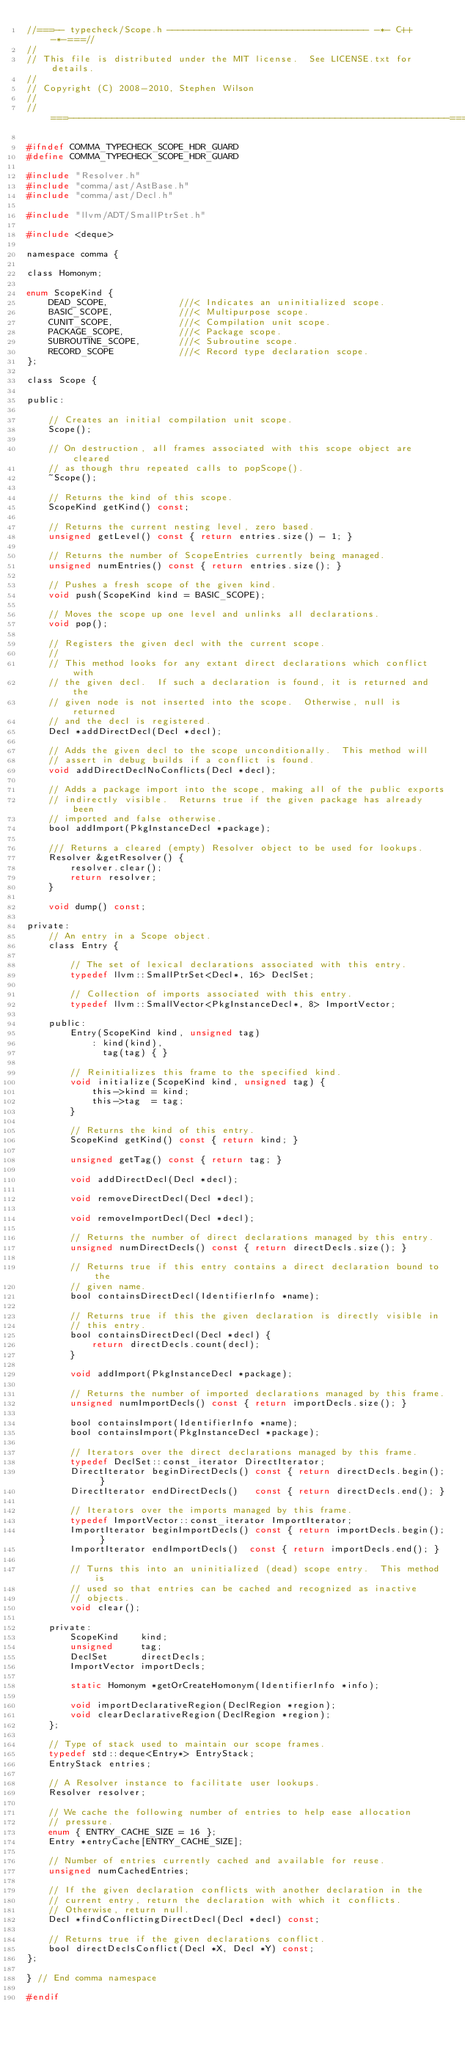<code> <loc_0><loc_0><loc_500><loc_500><_C_>//===-- typecheck/Scope.h ------------------------------------- -*- C++ -*-===//
//
// This file is distributed under the MIT license.  See LICENSE.txt for details.
//
// Copyright (C) 2008-2010, Stephen Wilson
//
//===----------------------------------------------------------------------===//

#ifndef COMMA_TYPECHECK_SCOPE_HDR_GUARD
#define COMMA_TYPECHECK_SCOPE_HDR_GUARD

#include "Resolver.h"
#include "comma/ast/AstBase.h"
#include "comma/ast/Decl.h"

#include "llvm/ADT/SmallPtrSet.h"

#include <deque>

namespace comma {

class Homonym;

enum ScopeKind {
    DEAD_SCOPE,             ///< Indicates an uninitialized scope.
    BASIC_SCOPE,            ///< Multipurpose scope.
    CUNIT_SCOPE,            ///< Compilation unit scope.
    PACKAGE_SCOPE,          ///< Package scope.
    SUBROUTINE_SCOPE,       ///< Subroutine scope.
    RECORD_SCOPE            ///< Record type declaration scope.
};

class Scope {

public:

    // Creates an initial compilation unit scope.
    Scope();

    // On destruction, all frames associated with this scope object are cleared
    // as though thru repeated calls to popScope().
    ~Scope();

    // Returns the kind of this scope.
    ScopeKind getKind() const;

    // Returns the current nesting level, zero based.
    unsigned getLevel() const { return entries.size() - 1; }

    // Returns the number of ScopeEntries currently being managed.
    unsigned numEntries() const { return entries.size(); }

    // Pushes a fresh scope of the given kind.
    void push(ScopeKind kind = BASIC_SCOPE);

    // Moves the scope up one level and unlinks all declarations.
    void pop();

    // Registers the given decl with the current scope.
    //
    // This method looks for any extant direct declarations which conflict with
    // the given decl.  If such a declaration is found, it is returned and the
    // given node is not inserted into the scope.  Otherwise, null is returned
    // and the decl is registered.
    Decl *addDirectDecl(Decl *decl);

    // Adds the given decl to the scope unconditionally.  This method will
    // assert in debug builds if a conflict is found.
    void addDirectDeclNoConflicts(Decl *decl);

    // Adds a package import into the scope, making all of the public exports
    // indirectly visible.  Returns true if the given package has already been
    // imported and false otherwise.
    bool addImport(PkgInstanceDecl *package);

    /// Returns a cleared (empty) Resolver object to be used for lookups.
    Resolver &getResolver() {
        resolver.clear();
        return resolver;
    }

    void dump() const;

private:
    // An entry in a Scope object.
    class Entry {

        // The set of lexical declarations associated with this entry.
        typedef llvm::SmallPtrSet<Decl*, 16> DeclSet;

        // Collection of imports associated with this entry.
        typedef llvm::SmallVector<PkgInstanceDecl*, 8> ImportVector;

    public:
        Entry(ScopeKind kind, unsigned tag)
            : kind(kind),
              tag(tag) { }

        // Reinitializes this frame to the specified kind.
        void initialize(ScopeKind kind, unsigned tag) {
            this->kind = kind;
            this->tag  = tag;
        }

        // Returns the kind of this entry.
        ScopeKind getKind() const { return kind; }

        unsigned getTag() const { return tag; }

        void addDirectDecl(Decl *decl);

        void removeDirectDecl(Decl *decl);

        void removeImportDecl(Decl *decl);

        // Returns the number of direct declarations managed by this entry.
        unsigned numDirectDecls() const { return directDecls.size(); }

        // Returns true if this entry contains a direct declaration bound to the
        // given name.
        bool containsDirectDecl(IdentifierInfo *name);

        // Returns true if this the given declaration is directly visible in
        // this entry.
        bool containsDirectDecl(Decl *decl) {
            return directDecls.count(decl);
        }

        void addImport(PkgInstanceDecl *package);

        // Returns the number of imported declarations managed by this frame.
        unsigned numImportDecls() const { return importDecls.size(); }

        bool containsImport(IdentifierInfo *name);
        bool containsImport(PkgInstanceDecl *package);

        // Iterators over the direct declarations managed by this frame.
        typedef DeclSet::const_iterator DirectIterator;
        DirectIterator beginDirectDecls() const { return directDecls.begin(); }
        DirectIterator endDirectDecls()   const { return directDecls.end(); }

        // Iterators over the imports managed by this frame.
        typedef ImportVector::const_iterator ImportIterator;
        ImportIterator beginImportDecls() const { return importDecls.begin(); }
        ImportIterator endImportDecls()  const { return importDecls.end(); }

        // Turns this into an uninitialized (dead) scope entry.  This method is
        // used so that entries can be cached and recognized as inactive
        // objects.
        void clear();

    private:
        ScopeKind    kind;
        unsigned     tag;
        DeclSet      directDecls;
        ImportVector importDecls;

        static Homonym *getOrCreateHomonym(IdentifierInfo *info);

        void importDeclarativeRegion(DeclRegion *region);
        void clearDeclarativeRegion(DeclRegion *region);
    };

    // Type of stack used to maintain our scope frames.
    typedef std::deque<Entry*> EntryStack;
    EntryStack entries;

    // A Resolver instance to facilitate user lookups.
    Resolver resolver;

    // We cache the following number of entries to help ease allocation
    // pressure.
    enum { ENTRY_CACHE_SIZE = 16 };
    Entry *entryCache[ENTRY_CACHE_SIZE];

    // Number of entries currently cached and available for reuse.
    unsigned numCachedEntries;

    // If the given declaration conflicts with another declaration in the
    // current entry, return the declaration with which it conflicts.
    // Otherwise, return null.
    Decl *findConflictingDirectDecl(Decl *decl) const;

    // Returns true if the given declarations conflict.
    bool directDeclsConflict(Decl *X, Decl *Y) const;
};

} // End comma namespace

#endif
</code> 